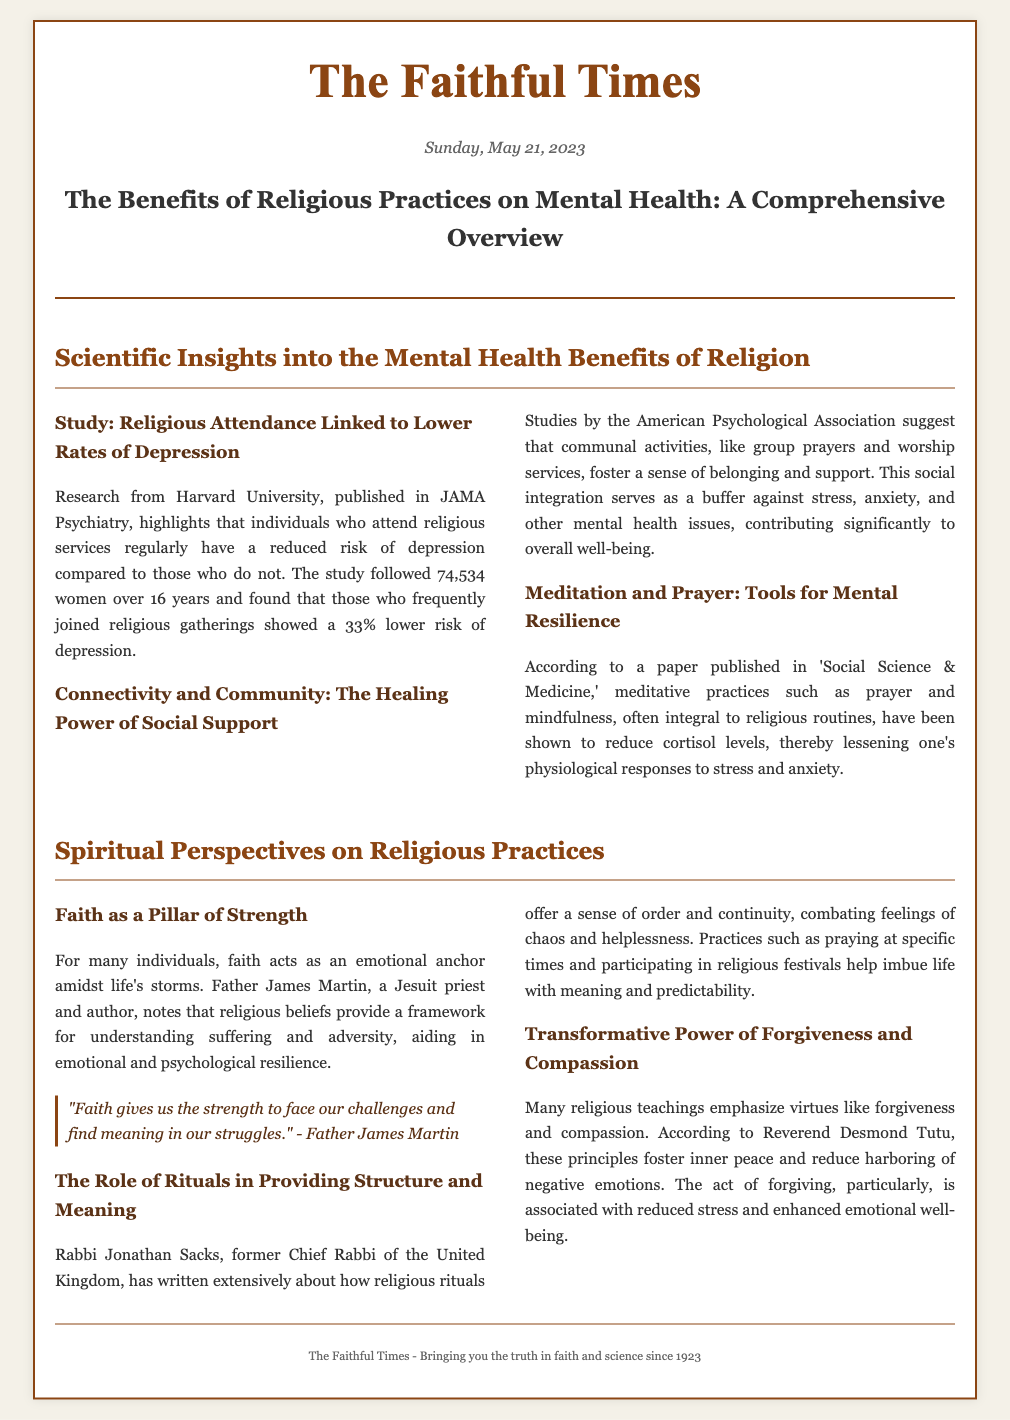What is the title of the article? The title of the article is prominently displayed under the header, summarizing its main theme.
Answer: The Benefits of Religious Practices on Mental Health: A Comprehensive Overview What percentage lower is the risk of depression for those attending religious services regularly? This percentage is provided in the summary of the study's findings related to religious attendance and mental health.
Answer: 33% Who conducted the research linking religious attendance to lower rates of depression? The document specifies that this research was conducted by a well-known institution and published in a reputable journal.
Answer: Harvard University What is one of the key phrases used by Father James Martin regarding faith? The quote encapsulates the essence of faith's role in providing emotional support during tough times.
Answer: "Faith gives us the strength to face our challenges and find meaning in our struggles." Which virtues are emphasized in many religious teachings according to Reverend Desmond Tutu? This information can be found in the section discussing transformative principles of religion and their impact on mental health.
Answer: Forgiveness and compassion What is the publication date of The Faithful Times? The date is clearly indicated beneath the newspaper's title and reflects the timing of the article's release.
Answer: Sunday, May 21, 2023 What types of practices are mentioned as tools for mental resilience? This type of practice is referred to in the context of meditative and spiritual routines essential to many religious traditions.
Answer: Meditation and prayer Which organization provided studies highlighting the importance of social support through communal activities? The document attributes these findings to an authoritative body in psychology that emphasizes community roles in mental health.
Answer: American Psychological Association 